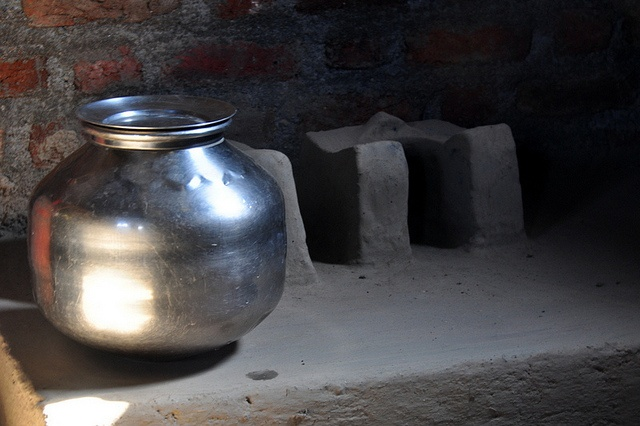Describe the objects in this image and their specific colors. I can see various objects in this image with different colors. 